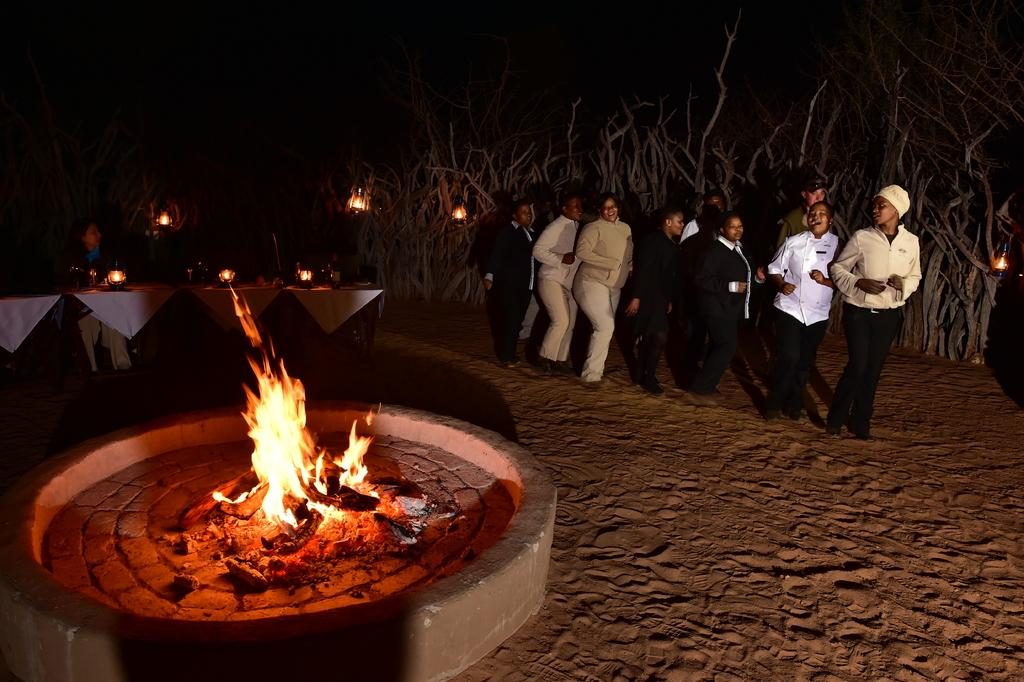What is the surface that the people are standing on in the image? The people are standing in the sand. What type of vegetation can be seen in the image? There are trees in the image. What is the source of light or heat in the image? There is a fire in the image. Are there cherries growing on the trees in the image? There is no information about cherries or any specific type of fruit growing on the trees in the image. What room is the fire located in the image? The image does not depict a room; it shows people standing in the sand with trees and a fire. 